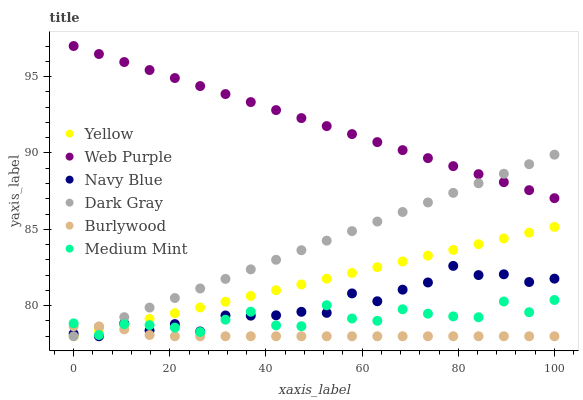Does Burlywood have the minimum area under the curve?
Answer yes or no. Yes. Does Web Purple have the maximum area under the curve?
Answer yes or no. Yes. Does Navy Blue have the minimum area under the curve?
Answer yes or no. No. Does Navy Blue have the maximum area under the curve?
Answer yes or no. No. Is Yellow the smoothest?
Answer yes or no. Yes. Is Medium Mint the roughest?
Answer yes or no. Yes. Is Burlywood the smoothest?
Answer yes or no. No. Is Burlywood the roughest?
Answer yes or no. No. Does Burlywood have the lowest value?
Answer yes or no. Yes. Does Web Purple have the lowest value?
Answer yes or no. No. Does Web Purple have the highest value?
Answer yes or no. Yes. Does Navy Blue have the highest value?
Answer yes or no. No. Is Yellow less than Web Purple?
Answer yes or no. Yes. Is Web Purple greater than Navy Blue?
Answer yes or no. Yes. Does Navy Blue intersect Burlywood?
Answer yes or no. Yes. Is Navy Blue less than Burlywood?
Answer yes or no. No. Is Navy Blue greater than Burlywood?
Answer yes or no. No. Does Yellow intersect Web Purple?
Answer yes or no. No. 